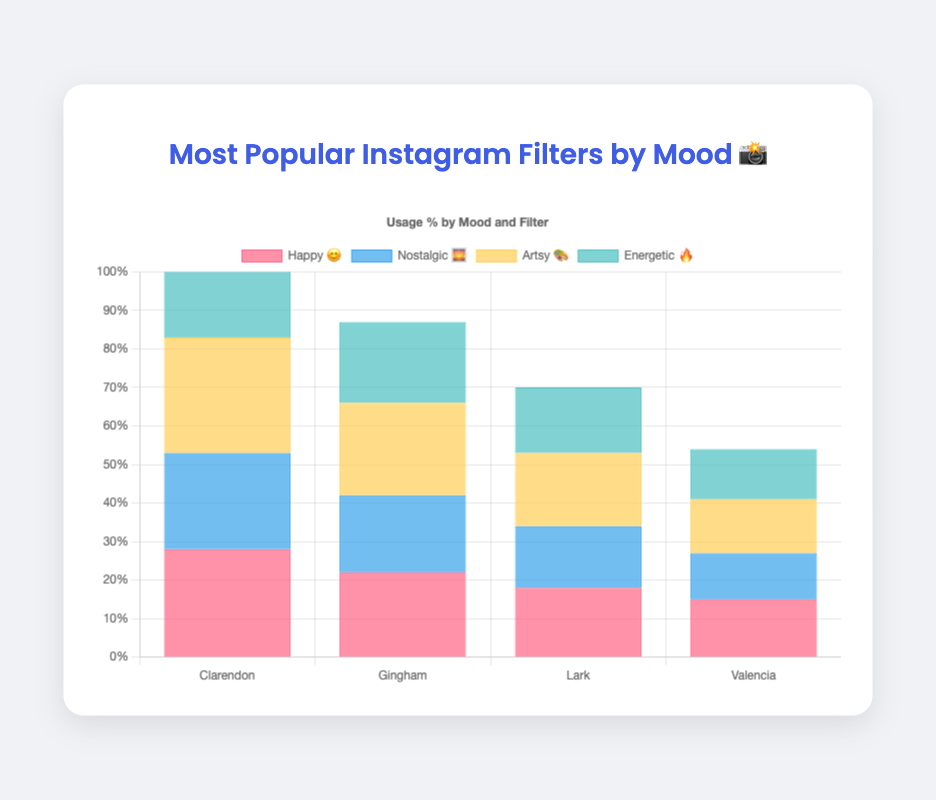Which mood category has the highest usage of an Instagram filter? The highest usage in any mood category can be identified by checking the maximum value in each category. The "Artsy 🎨" mood has the highest usage with Juno at 30%.
Answer: Artsy 🎨 Which filters have the highest usage in the "Happy 😊" mood? The filters in the "Happy 😊" mood sorted by usage are Clarendon (28%), Gingham (22%), Lark (18%), and Valencia (15%). Clarendon has the highest usage.
Answer: Clarendon What is the combined usage percentage of the top two filters in the "Nostalgic 🌅" mood? The top two filters in the "Nostalgic 🌅" mood are 1977 (25%) and Aden (20%). Their combined usage is 25% + 20% = 45%.
Answer: 45% Which filter has the lowest usage in the "Energetic 🔥" mood? The filters in the "Energetic 🔥" mood sorted by usage are X-Pro II (26%), Lo-Fi (21%), Amaro (17%), and Mayfair (13%). Mayfair has the lowest usage.
Answer: Mayfair Compare the usage of Gingham in the "Happy 😊" mood and Inkwell in the "Artsy 🎨" mood. Which one is higher? Gingham has a usage of 22% in the "Happy 😊" mood and Inkwell has a usage of 24% in the "Artsy 🎨" mood. Inkwell has a higher usage.
Answer: Inkwell Among Juno, Clarendon, and X-Pro II, which filter has the highest usage? Juno has the highest usage at 30%, followed by Clarendon at 28%, and X-Pro II at 26%. Therefore, Juno has the highest usage.
Answer: Juno Calculate the average usage of the filters in the "Artsy 🎨" mood. The filters in the "Artsy 🎨" mood have usage percentages of 30%, 24%, 19%, and 14%. The average usage is (30 + 24 + 19 + 14) / 4 = 21.75%.
Answer: 21.75% 